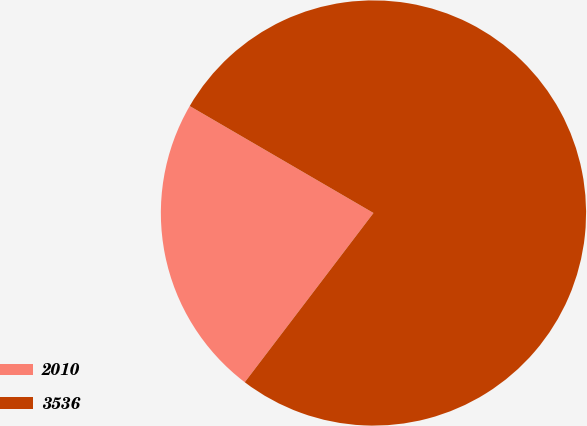Convert chart. <chart><loc_0><loc_0><loc_500><loc_500><pie_chart><fcel>2010<fcel>3536<nl><fcel>23.04%<fcel>76.96%<nl></chart> 